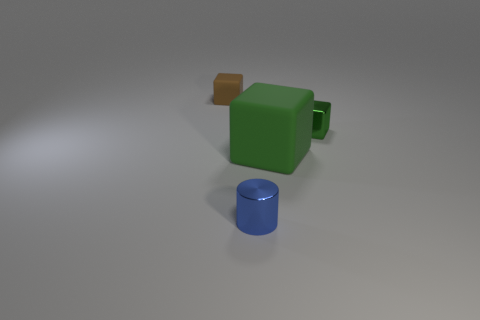The small matte block has what color?
Your answer should be compact. Brown. There is a matte thing to the right of the tiny brown rubber thing; is its shape the same as the tiny green thing?
Provide a succinct answer. Yes. What is the material of the small brown cube?
Provide a short and direct response. Rubber. The blue object that is the same size as the brown object is what shape?
Ensure brevity in your answer.  Cylinder. Is there a tiny shiny object of the same color as the small rubber object?
Your answer should be very brief. No. There is a small metallic cylinder; is it the same color as the matte cube that is to the left of the small blue object?
Your answer should be very brief. No. There is a tiny thing that is behind the tiny metallic thing that is to the right of the large block; what is its color?
Provide a short and direct response. Brown. Are there any small metal cylinders that are behind the shiny object that is in front of the small thing that is right of the small shiny cylinder?
Your response must be concise. No. There is a small cube that is the same material as the small cylinder; what color is it?
Offer a very short reply. Green. How many other cubes are the same material as the large green cube?
Keep it short and to the point. 1. 